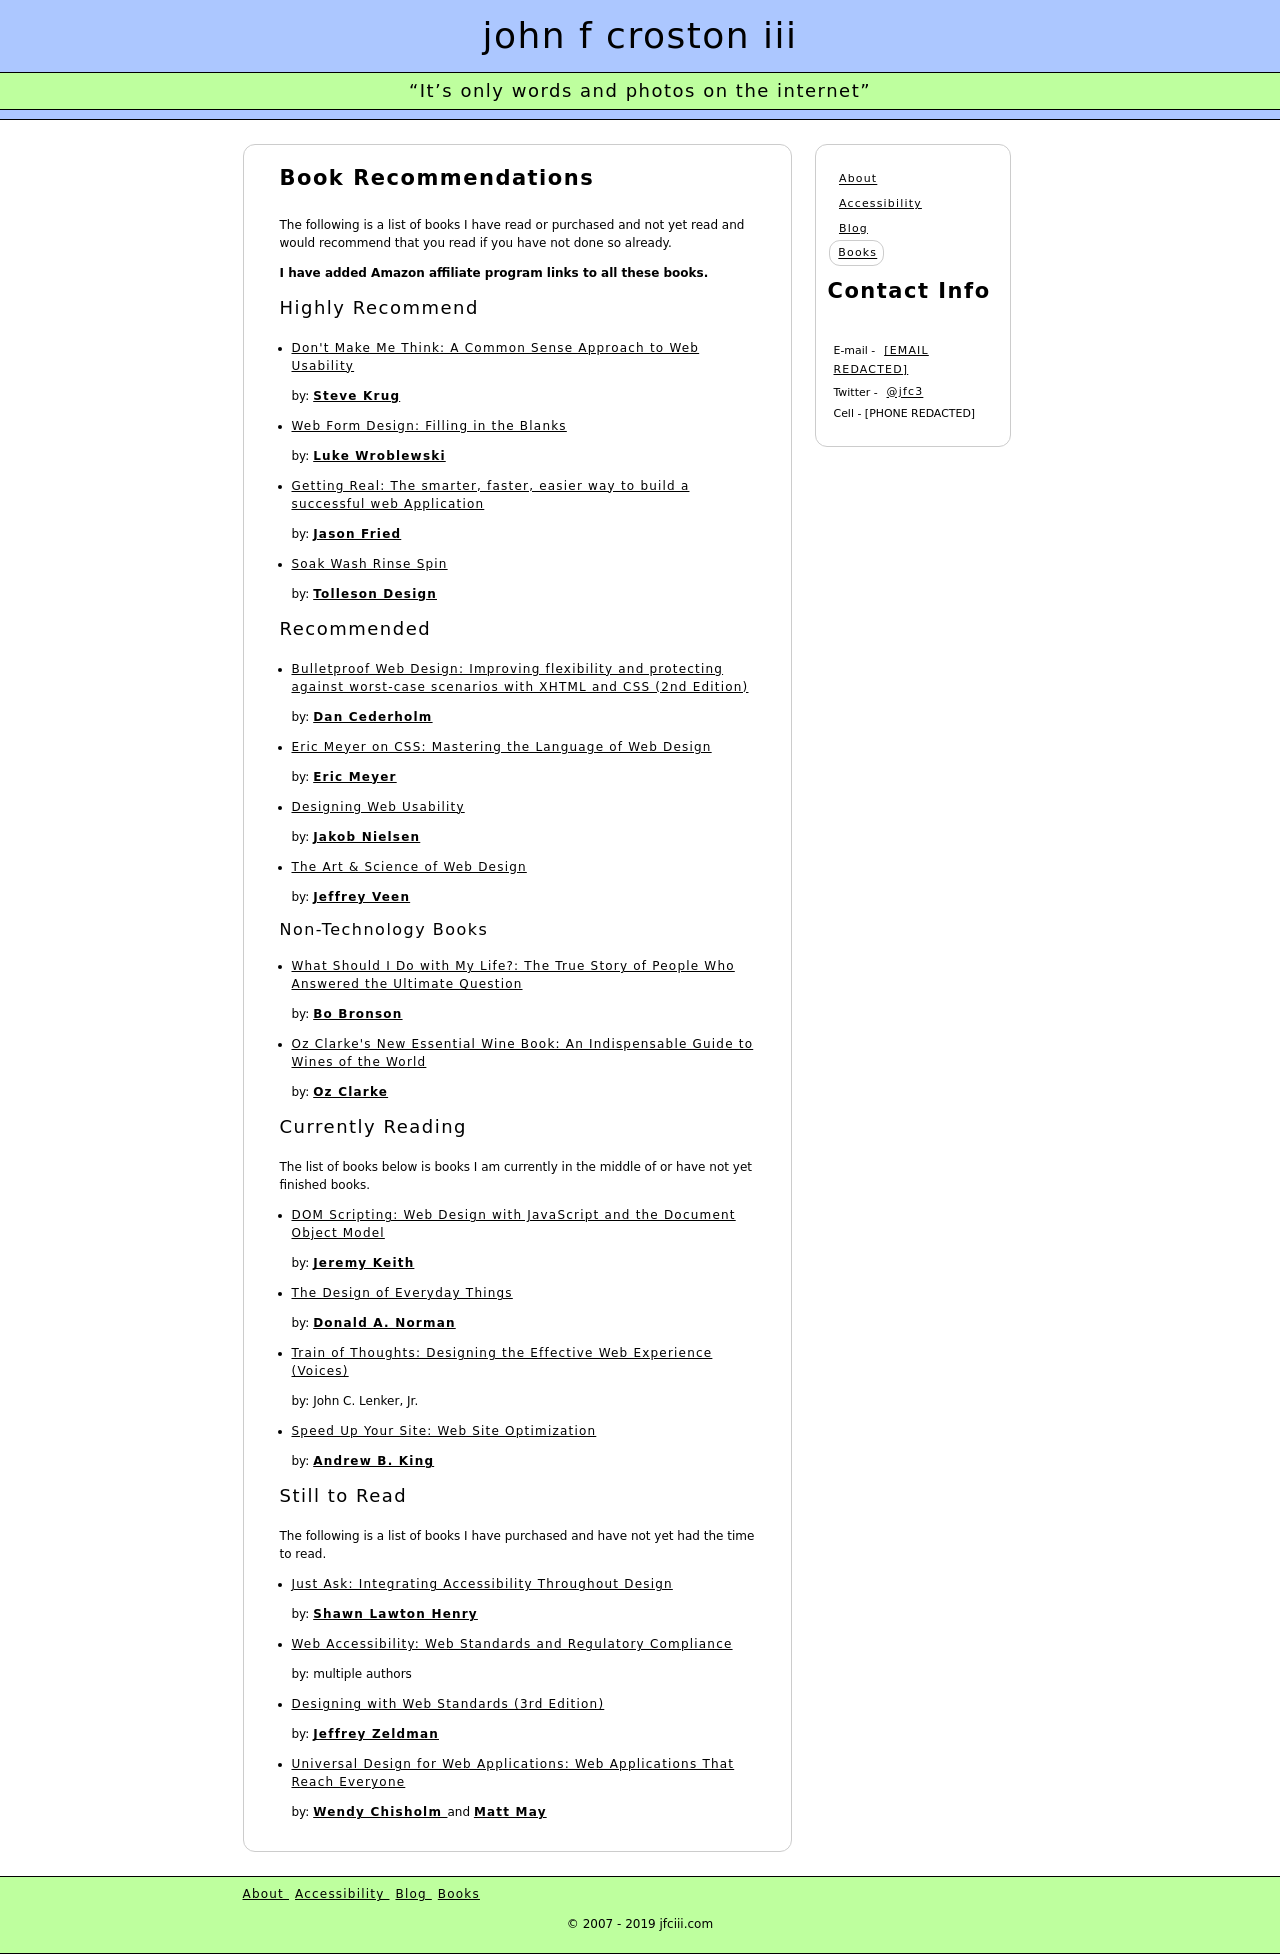Could you detail the process for assembling this website using HTML? To create a website similar to the one depicted in the image, you would start with a basic HTML structure including doctype, html tag, head, and body sections. Inside the body, you'd use div tags to create sections like 'header', 'main_content', and 'footer'. For each book listed, you could use additional div or article tags, each containing h1 or h2 tags for titles and p tags for descriptions. CSS would be used for styling to mimic the visual layout shown in the image, including colors, fonts, and arrangements. JavaScript could be utilized for interactive elements such as sorting or filtering the listed books. 